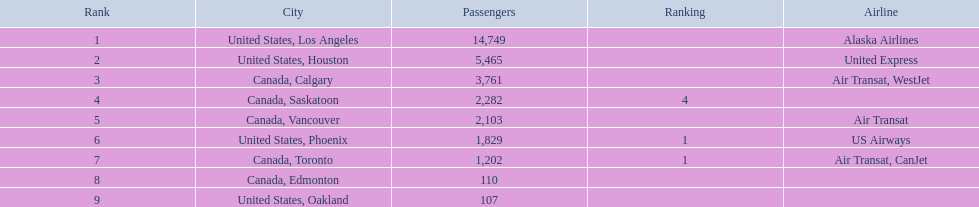Which cities had fewer than 2,000 passengers? United States, Phoenix, Canada, Toronto, Canada, Edmonton, United States, Oakland. Of these cities, which had less than 1,000 passengers? Canada, Edmonton, United States, Oakland. Of the cities in the preceding answer, which one had precisely 107 passengers? United States, Oakland. 